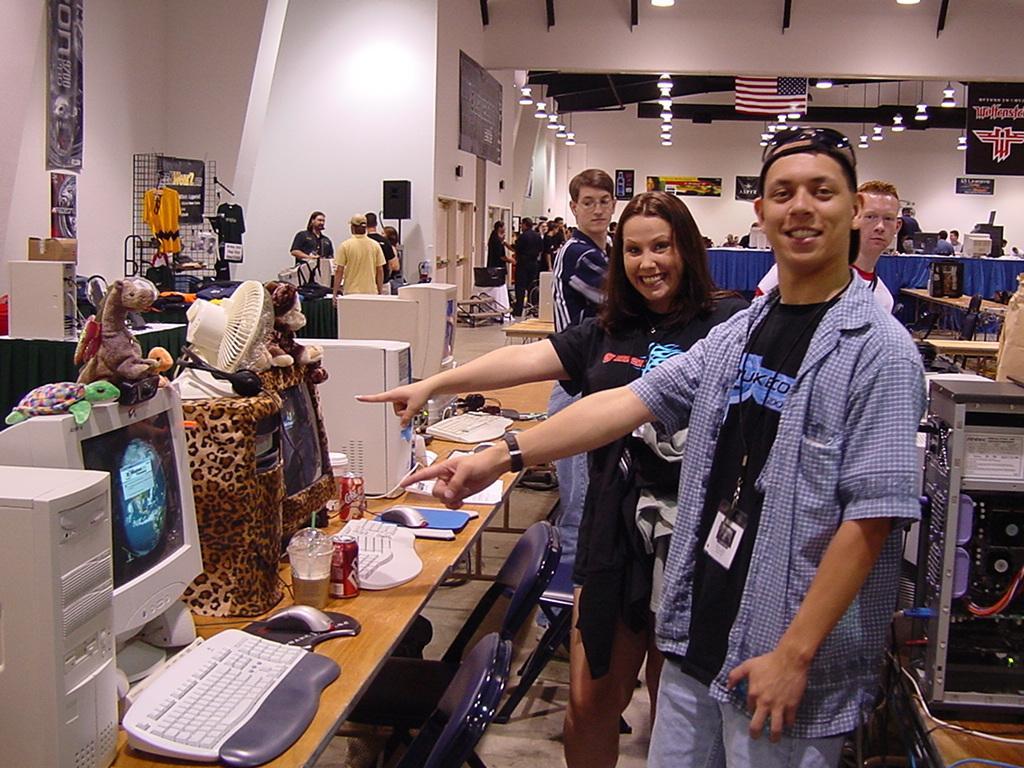Describe this image in one or two sentences. This picture is clicked inside the hall and we can see the group of people and we can see the monitors and the electronic devices which are placed on the top of the tables and we can see the cans, glasses of drinks and some other objects. In the background we can see the wall, text on the posters and we can see the flag and lights and we can see the chairs and many other objects. 